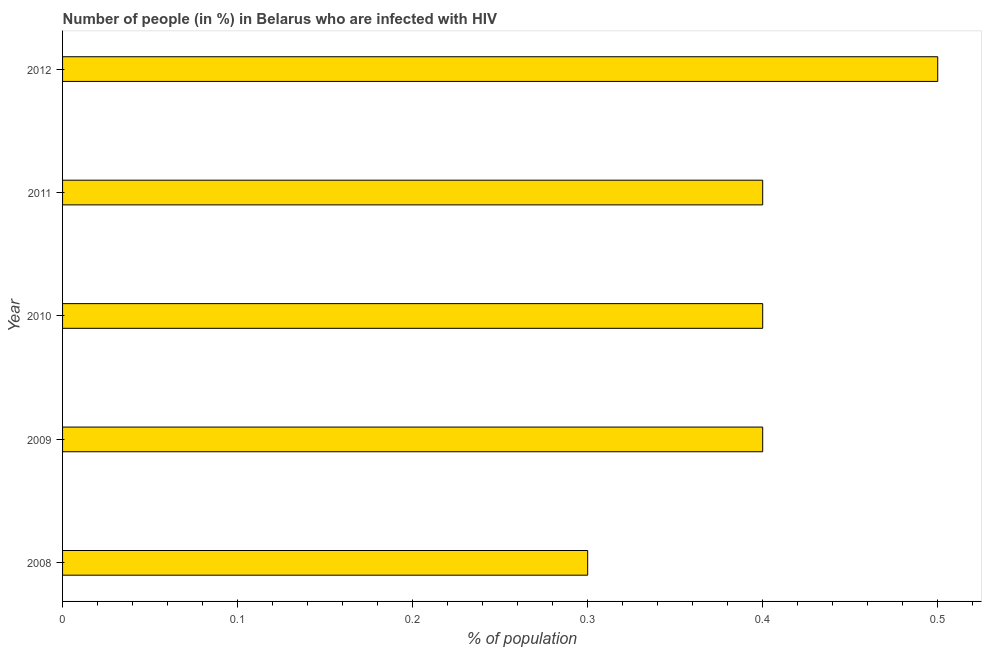What is the title of the graph?
Make the answer very short. Number of people (in %) in Belarus who are infected with HIV. What is the label or title of the X-axis?
Ensure brevity in your answer.  % of population. What is the label or title of the Y-axis?
Provide a short and direct response. Year. Across all years, what is the minimum number of people infected with hiv?
Offer a terse response. 0.3. What is the difference between the number of people infected with hiv in 2008 and 2009?
Provide a short and direct response. -0.1. What is the average number of people infected with hiv per year?
Ensure brevity in your answer.  0.4. Do a majority of the years between 2011 and 2012 (inclusive) have number of people infected with hiv greater than 0.46 %?
Ensure brevity in your answer.  No. Is the difference between the number of people infected with hiv in 2009 and 2012 greater than the difference between any two years?
Offer a terse response. No. What is the difference between the highest and the lowest number of people infected with hiv?
Keep it short and to the point. 0.2. In how many years, is the number of people infected with hiv greater than the average number of people infected with hiv taken over all years?
Provide a short and direct response. 1. Are all the bars in the graph horizontal?
Your response must be concise. Yes. What is the difference between two consecutive major ticks on the X-axis?
Your response must be concise. 0.1. Are the values on the major ticks of X-axis written in scientific E-notation?
Offer a terse response. No. What is the % of population in 2010?
Give a very brief answer. 0.4. What is the % of population in 2012?
Give a very brief answer. 0.5. What is the difference between the % of population in 2008 and 2009?
Your answer should be compact. -0.1. What is the difference between the % of population in 2008 and 2010?
Ensure brevity in your answer.  -0.1. What is the difference between the % of population in 2008 and 2011?
Your answer should be compact. -0.1. What is the difference between the % of population in 2010 and 2012?
Your answer should be compact. -0.1. What is the ratio of the % of population in 2008 to that in 2011?
Provide a short and direct response. 0.75. What is the ratio of the % of population in 2008 to that in 2012?
Make the answer very short. 0.6. What is the ratio of the % of population in 2009 to that in 2010?
Offer a very short reply. 1. What is the ratio of the % of population in 2009 to that in 2011?
Offer a terse response. 1. What is the ratio of the % of population in 2010 to that in 2011?
Ensure brevity in your answer.  1. What is the ratio of the % of population in 2010 to that in 2012?
Make the answer very short. 0.8. What is the ratio of the % of population in 2011 to that in 2012?
Provide a succinct answer. 0.8. 